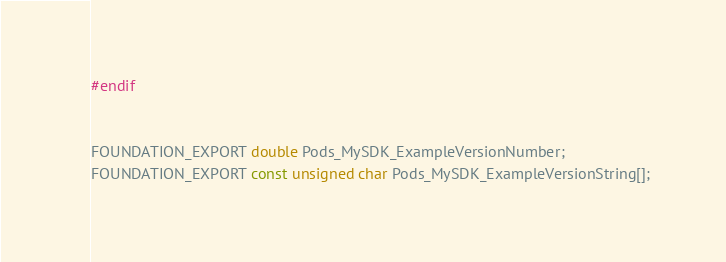<code> <loc_0><loc_0><loc_500><loc_500><_C_>#endif


FOUNDATION_EXPORT double Pods_MySDK_ExampleVersionNumber;
FOUNDATION_EXPORT const unsigned char Pods_MySDK_ExampleVersionString[];

</code> 